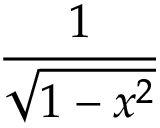Convert formula to latex. <formula><loc_0><loc_0><loc_500><loc_500>\frac { 1 } { \sqrt { 1 - x ^ { 2 } } }</formula> 